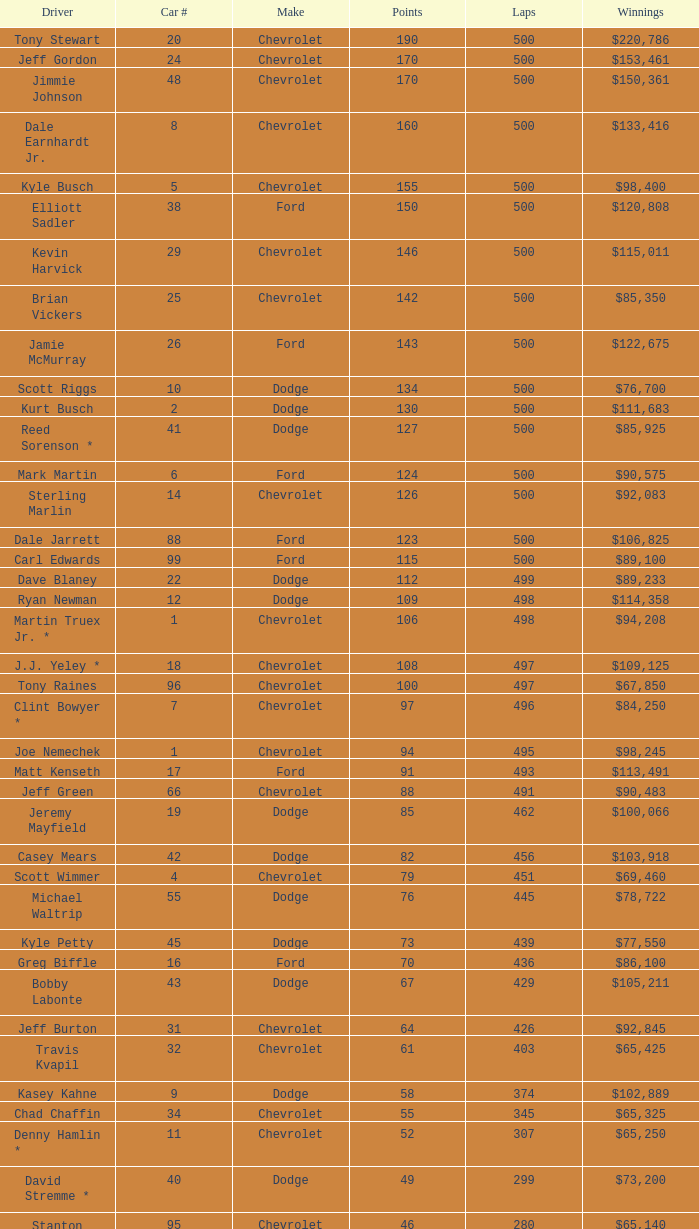What is the average car number of all the drivers who have won $111,683? 2.0. 